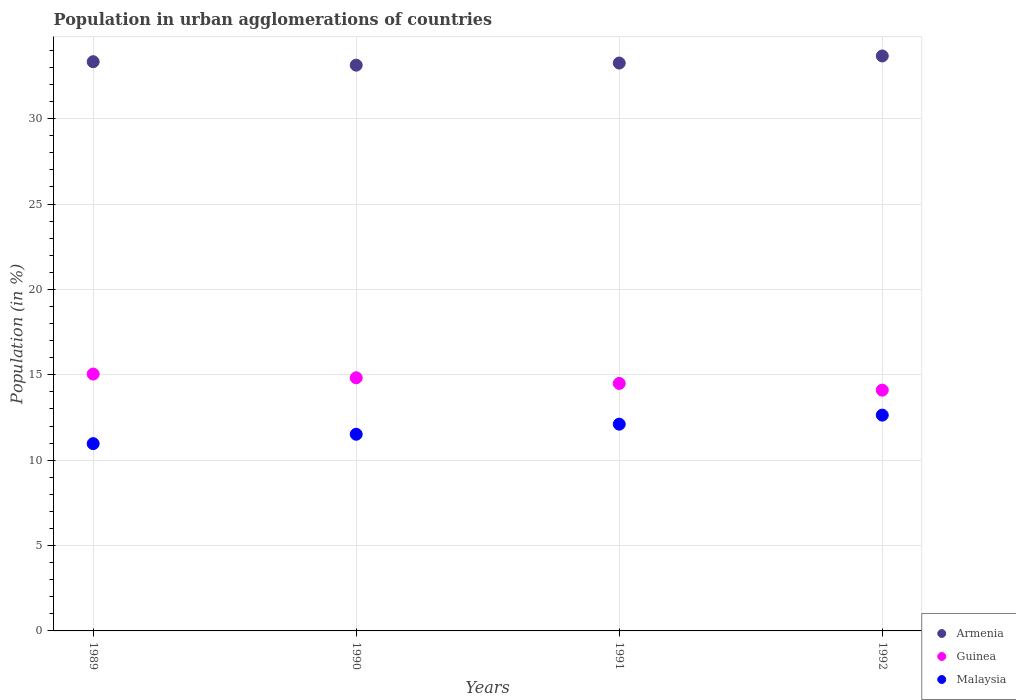Is the number of dotlines equal to the number of legend labels?
Your answer should be very brief. Yes. What is the percentage of population in urban agglomerations in Armenia in 1989?
Ensure brevity in your answer.  33.34. Across all years, what is the maximum percentage of population in urban agglomerations in Guinea?
Offer a very short reply. 15.04. Across all years, what is the minimum percentage of population in urban agglomerations in Armenia?
Your answer should be compact. 33.13. In which year was the percentage of population in urban agglomerations in Guinea minimum?
Make the answer very short. 1992. What is the total percentage of population in urban agglomerations in Guinea in the graph?
Keep it short and to the point. 58.46. What is the difference between the percentage of population in urban agglomerations in Guinea in 1989 and that in 1991?
Provide a succinct answer. 0.55. What is the difference between the percentage of population in urban agglomerations in Malaysia in 1989 and the percentage of population in urban agglomerations in Armenia in 1990?
Offer a terse response. -22.17. What is the average percentage of population in urban agglomerations in Armenia per year?
Offer a terse response. 33.35. In the year 1990, what is the difference between the percentage of population in urban agglomerations in Armenia and percentage of population in urban agglomerations in Malaysia?
Provide a succinct answer. 21.62. In how many years, is the percentage of population in urban agglomerations in Guinea greater than 9 %?
Ensure brevity in your answer.  4. What is the ratio of the percentage of population in urban agglomerations in Guinea in 1990 to that in 1991?
Keep it short and to the point. 1.02. What is the difference between the highest and the second highest percentage of population in urban agglomerations in Guinea?
Give a very brief answer. 0.22. What is the difference between the highest and the lowest percentage of population in urban agglomerations in Malaysia?
Your answer should be compact. 1.67. Is the sum of the percentage of population in urban agglomerations in Guinea in 1990 and 1991 greater than the maximum percentage of population in urban agglomerations in Malaysia across all years?
Ensure brevity in your answer.  Yes. Is it the case that in every year, the sum of the percentage of population in urban agglomerations in Guinea and percentage of population in urban agglomerations in Armenia  is greater than the percentage of population in urban agglomerations in Malaysia?
Keep it short and to the point. Yes. Does the percentage of population in urban agglomerations in Malaysia monotonically increase over the years?
Provide a short and direct response. Yes. Is the percentage of population in urban agglomerations in Armenia strictly less than the percentage of population in urban agglomerations in Guinea over the years?
Provide a short and direct response. No. How many years are there in the graph?
Your answer should be compact. 4. Are the values on the major ticks of Y-axis written in scientific E-notation?
Your response must be concise. No. Where does the legend appear in the graph?
Provide a succinct answer. Bottom right. How many legend labels are there?
Offer a very short reply. 3. How are the legend labels stacked?
Give a very brief answer. Vertical. What is the title of the graph?
Offer a terse response. Population in urban agglomerations of countries. Does "Iraq" appear as one of the legend labels in the graph?
Give a very brief answer. No. What is the label or title of the X-axis?
Provide a short and direct response. Years. What is the label or title of the Y-axis?
Provide a short and direct response. Population (in %). What is the Population (in %) in Armenia in 1989?
Provide a succinct answer. 33.34. What is the Population (in %) in Guinea in 1989?
Offer a very short reply. 15.04. What is the Population (in %) of Malaysia in 1989?
Provide a succinct answer. 10.97. What is the Population (in %) in Armenia in 1990?
Provide a short and direct response. 33.13. What is the Population (in %) of Guinea in 1990?
Give a very brief answer. 14.83. What is the Population (in %) in Malaysia in 1990?
Ensure brevity in your answer.  11.52. What is the Population (in %) of Armenia in 1991?
Provide a short and direct response. 33.26. What is the Population (in %) of Guinea in 1991?
Make the answer very short. 14.49. What is the Population (in %) of Malaysia in 1991?
Offer a terse response. 12.11. What is the Population (in %) of Armenia in 1992?
Make the answer very short. 33.67. What is the Population (in %) of Guinea in 1992?
Provide a short and direct response. 14.1. What is the Population (in %) in Malaysia in 1992?
Ensure brevity in your answer.  12.64. Across all years, what is the maximum Population (in %) of Armenia?
Offer a very short reply. 33.67. Across all years, what is the maximum Population (in %) of Guinea?
Keep it short and to the point. 15.04. Across all years, what is the maximum Population (in %) of Malaysia?
Provide a succinct answer. 12.64. Across all years, what is the minimum Population (in %) in Armenia?
Ensure brevity in your answer.  33.13. Across all years, what is the minimum Population (in %) in Guinea?
Make the answer very short. 14.1. Across all years, what is the minimum Population (in %) of Malaysia?
Provide a short and direct response. 10.97. What is the total Population (in %) of Armenia in the graph?
Offer a terse response. 133.41. What is the total Population (in %) in Guinea in the graph?
Your response must be concise. 58.46. What is the total Population (in %) of Malaysia in the graph?
Provide a short and direct response. 47.24. What is the difference between the Population (in %) of Armenia in 1989 and that in 1990?
Offer a terse response. 0.2. What is the difference between the Population (in %) of Guinea in 1989 and that in 1990?
Give a very brief answer. 0.22. What is the difference between the Population (in %) in Malaysia in 1989 and that in 1990?
Offer a very short reply. -0.55. What is the difference between the Population (in %) in Armenia in 1989 and that in 1991?
Provide a succinct answer. 0.08. What is the difference between the Population (in %) in Guinea in 1989 and that in 1991?
Offer a terse response. 0.55. What is the difference between the Population (in %) in Malaysia in 1989 and that in 1991?
Keep it short and to the point. -1.14. What is the difference between the Population (in %) in Armenia in 1989 and that in 1992?
Ensure brevity in your answer.  -0.34. What is the difference between the Population (in %) in Guinea in 1989 and that in 1992?
Your response must be concise. 0.94. What is the difference between the Population (in %) in Malaysia in 1989 and that in 1992?
Give a very brief answer. -1.67. What is the difference between the Population (in %) in Armenia in 1990 and that in 1991?
Make the answer very short. -0.12. What is the difference between the Population (in %) in Guinea in 1990 and that in 1991?
Provide a succinct answer. 0.33. What is the difference between the Population (in %) in Malaysia in 1990 and that in 1991?
Your answer should be very brief. -0.59. What is the difference between the Population (in %) of Armenia in 1990 and that in 1992?
Your answer should be very brief. -0.54. What is the difference between the Population (in %) in Guinea in 1990 and that in 1992?
Provide a succinct answer. 0.72. What is the difference between the Population (in %) in Malaysia in 1990 and that in 1992?
Your response must be concise. -1.12. What is the difference between the Population (in %) of Armenia in 1991 and that in 1992?
Offer a terse response. -0.41. What is the difference between the Population (in %) in Guinea in 1991 and that in 1992?
Give a very brief answer. 0.39. What is the difference between the Population (in %) in Malaysia in 1991 and that in 1992?
Your response must be concise. -0.53. What is the difference between the Population (in %) of Armenia in 1989 and the Population (in %) of Guinea in 1990?
Give a very brief answer. 18.51. What is the difference between the Population (in %) of Armenia in 1989 and the Population (in %) of Malaysia in 1990?
Your answer should be compact. 21.82. What is the difference between the Population (in %) in Guinea in 1989 and the Population (in %) in Malaysia in 1990?
Provide a succinct answer. 3.53. What is the difference between the Population (in %) of Armenia in 1989 and the Population (in %) of Guinea in 1991?
Keep it short and to the point. 18.84. What is the difference between the Population (in %) in Armenia in 1989 and the Population (in %) in Malaysia in 1991?
Make the answer very short. 21.23. What is the difference between the Population (in %) of Guinea in 1989 and the Population (in %) of Malaysia in 1991?
Ensure brevity in your answer.  2.94. What is the difference between the Population (in %) in Armenia in 1989 and the Population (in %) in Guinea in 1992?
Your answer should be very brief. 19.24. What is the difference between the Population (in %) in Armenia in 1989 and the Population (in %) in Malaysia in 1992?
Your answer should be very brief. 20.7. What is the difference between the Population (in %) in Guinea in 1989 and the Population (in %) in Malaysia in 1992?
Offer a very short reply. 2.4. What is the difference between the Population (in %) in Armenia in 1990 and the Population (in %) in Guinea in 1991?
Give a very brief answer. 18.64. What is the difference between the Population (in %) in Armenia in 1990 and the Population (in %) in Malaysia in 1991?
Offer a terse response. 21.03. What is the difference between the Population (in %) of Guinea in 1990 and the Population (in %) of Malaysia in 1991?
Your answer should be very brief. 2.72. What is the difference between the Population (in %) of Armenia in 1990 and the Population (in %) of Guinea in 1992?
Your answer should be very brief. 19.03. What is the difference between the Population (in %) of Armenia in 1990 and the Population (in %) of Malaysia in 1992?
Provide a short and direct response. 20.49. What is the difference between the Population (in %) in Guinea in 1990 and the Population (in %) in Malaysia in 1992?
Provide a succinct answer. 2.19. What is the difference between the Population (in %) in Armenia in 1991 and the Population (in %) in Guinea in 1992?
Your answer should be very brief. 19.16. What is the difference between the Population (in %) in Armenia in 1991 and the Population (in %) in Malaysia in 1992?
Your answer should be compact. 20.62. What is the difference between the Population (in %) of Guinea in 1991 and the Population (in %) of Malaysia in 1992?
Provide a succinct answer. 1.85. What is the average Population (in %) of Armenia per year?
Offer a terse response. 33.35. What is the average Population (in %) of Guinea per year?
Provide a succinct answer. 14.62. What is the average Population (in %) in Malaysia per year?
Provide a short and direct response. 11.81. In the year 1989, what is the difference between the Population (in %) in Armenia and Population (in %) in Guinea?
Keep it short and to the point. 18.29. In the year 1989, what is the difference between the Population (in %) in Armenia and Population (in %) in Malaysia?
Give a very brief answer. 22.37. In the year 1989, what is the difference between the Population (in %) in Guinea and Population (in %) in Malaysia?
Make the answer very short. 4.08. In the year 1990, what is the difference between the Population (in %) of Armenia and Population (in %) of Guinea?
Offer a very short reply. 18.31. In the year 1990, what is the difference between the Population (in %) in Armenia and Population (in %) in Malaysia?
Provide a succinct answer. 21.62. In the year 1990, what is the difference between the Population (in %) of Guinea and Population (in %) of Malaysia?
Ensure brevity in your answer.  3.31. In the year 1991, what is the difference between the Population (in %) of Armenia and Population (in %) of Guinea?
Your response must be concise. 18.77. In the year 1991, what is the difference between the Population (in %) of Armenia and Population (in %) of Malaysia?
Provide a short and direct response. 21.15. In the year 1991, what is the difference between the Population (in %) of Guinea and Population (in %) of Malaysia?
Provide a succinct answer. 2.38. In the year 1992, what is the difference between the Population (in %) of Armenia and Population (in %) of Guinea?
Ensure brevity in your answer.  19.57. In the year 1992, what is the difference between the Population (in %) in Armenia and Population (in %) in Malaysia?
Your answer should be compact. 21.03. In the year 1992, what is the difference between the Population (in %) of Guinea and Population (in %) of Malaysia?
Keep it short and to the point. 1.46. What is the ratio of the Population (in %) in Guinea in 1989 to that in 1990?
Your response must be concise. 1.01. What is the ratio of the Population (in %) of Malaysia in 1989 to that in 1990?
Make the answer very short. 0.95. What is the ratio of the Population (in %) in Armenia in 1989 to that in 1991?
Provide a succinct answer. 1. What is the ratio of the Population (in %) of Guinea in 1989 to that in 1991?
Ensure brevity in your answer.  1.04. What is the ratio of the Population (in %) of Malaysia in 1989 to that in 1991?
Offer a terse response. 0.91. What is the ratio of the Population (in %) in Armenia in 1989 to that in 1992?
Make the answer very short. 0.99. What is the ratio of the Population (in %) of Guinea in 1989 to that in 1992?
Your response must be concise. 1.07. What is the ratio of the Population (in %) of Malaysia in 1989 to that in 1992?
Your response must be concise. 0.87. What is the ratio of the Population (in %) in Armenia in 1990 to that in 1991?
Provide a succinct answer. 1. What is the ratio of the Population (in %) of Guinea in 1990 to that in 1991?
Your answer should be compact. 1.02. What is the ratio of the Population (in %) of Malaysia in 1990 to that in 1991?
Provide a short and direct response. 0.95. What is the ratio of the Population (in %) of Armenia in 1990 to that in 1992?
Provide a short and direct response. 0.98. What is the ratio of the Population (in %) of Guinea in 1990 to that in 1992?
Keep it short and to the point. 1.05. What is the ratio of the Population (in %) in Malaysia in 1990 to that in 1992?
Your answer should be compact. 0.91. What is the ratio of the Population (in %) of Guinea in 1991 to that in 1992?
Offer a terse response. 1.03. What is the ratio of the Population (in %) in Malaysia in 1991 to that in 1992?
Ensure brevity in your answer.  0.96. What is the difference between the highest and the second highest Population (in %) of Armenia?
Offer a terse response. 0.34. What is the difference between the highest and the second highest Population (in %) of Guinea?
Provide a short and direct response. 0.22. What is the difference between the highest and the second highest Population (in %) in Malaysia?
Make the answer very short. 0.53. What is the difference between the highest and the lowest Population (in %) of Armenia?
Keep it short and to the point. 0.54. What is the difference between the highest and the lowest Population (in %) of Guinea?
Provide a short and direct response. 0.94. What is the difference between the highest and the lowest Population (in %) of Malaysia?
Offer a terse response. 1.67. 